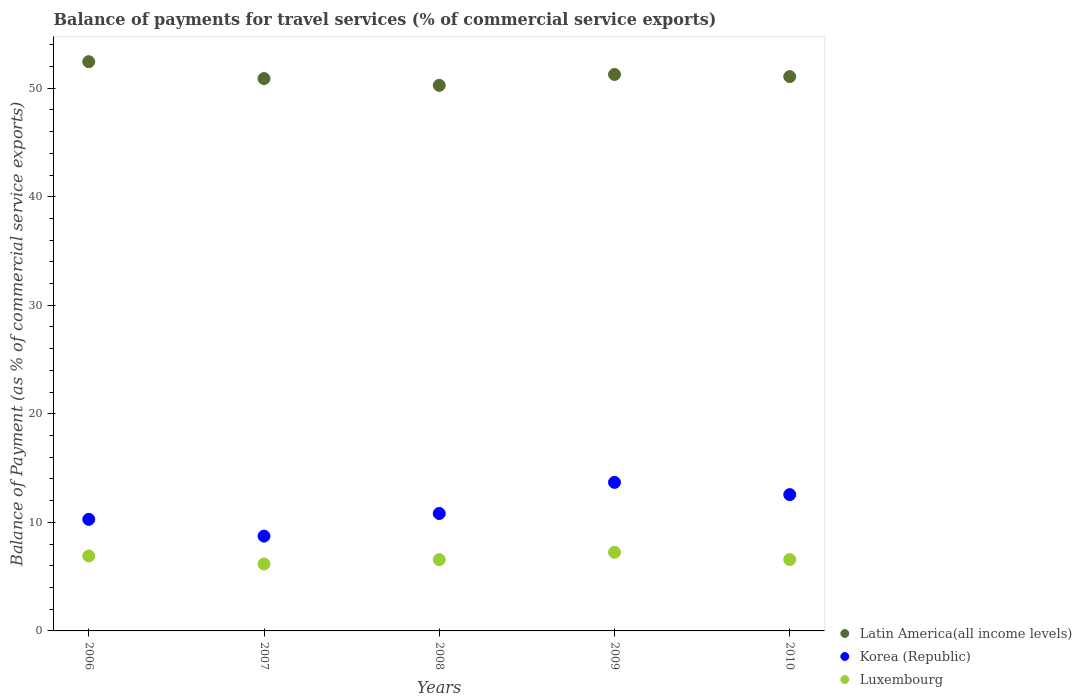Is the number of dotlines equal to the number of legend labels?
Your answer should be very brief. Yes. What is the balance of payments for travel services in Latin America(all income levels) in 2008?
Provide a short and direct response. 50.26. Across all years, what is the maximum balance of payments for travel services in Korea (Republic)?
Provide a succinct answer. 13.68. Across all years, what is the minimum balance of payments for travel services in Latin America(all income levels)?
Ensure brevity in your answer.  50.26. In which year was the balance of payments for travel services in Luxembourg maximum?
Your answer should be very brief. 2009. In which year was the balance of payments for travel services in Luxembourg minimum?
Ensure brevity in your answer.  2007. What is the total balance of payments for travel services in Luxembourg in the graph?
Give a very brief answer. 33.46. What is the difference between the balance of payments for travel services in Korea (Republic) in 2006 and that in 2010?
Give a very brief answer. -2.28. What is the difference between the balance of payments for travel services in Korea (Republic) in 2009 and the balance of payments for travel services in Luxembourg in 2008?
Offer a terse response. 7.12. What is the average balance of payments for travel services in Korea (Republic) per year?
Ensure brevity in your answer.  11.21. In the year 2008, what is the difference between the balance of payments for travel services in Luxembourg and balance of payments for travel services in Latin America(all income levels)?
Keep it short and to the point. -43.69. In how many years, is the balance of payments for travel services in Latin America(all income levels) greater than 46 %?
Offer a terse response. 5. What is the ratio of the balance of payments for travel services in Latin America(all income levels) in 2006 to that in 2010?
Provide a short and direct response. 1.03. Is the balance of payments for travel services in Luxembourg in 2008 less than that in 2010?
Your answer should be very brief. Yes. What is the difference between the highest and the second highest balance of payments for travel services in Latin America(all income levels)?
Provide a short and direct response. 1.18. What is the difference between the highest and the lowest balance of payments for travel services in Korea (Republic)?
Give a very brief answer. 4.95. In how many years, is the balance of payments for travel services in Korea (Republic) greater than the average balance of payments for travel services in Korea (Republic) taken over all years?
Your answer should be compact. 2. Is the sum of the balance of payments for travel services in Latin America(all income levels) in 2009 and 2010 greater than the maximum balance of payments for travel services in Korea (Republic) across all years?
Your response must be concise. Yes. Is the balance of payments for travel services in Luxembourg strictly greater than the balance of payments for travel services in Korea (Republic) over the years?
Keep it short and to the point. No. Is the balance of payments for travel services in Luxembourg strictly less than the balance of payments for travel services in Korea (Republic) over the years?
Your answer should be very brief. Yes. How many dotlines are there?
Provide a short and direct response. 3. How many years are there in the graph?
Your answer should be very brief. 5. What is the difference between two consecutive major ticks on the Y-axis?
Give a very brief answer. 10. Where does the legend appear in the graph?
Offer a very short reply. Bottom right. How are the legend labels stacked?
Offer a very short reply. Vertical. What is the title of the graph?
Your answer should be very brief. Balance of payments for travel services (% of commercial service exports). What is the label or title of the Y-axis?
Keep it short and to the point. Balance of Payment (as % of commercial service exports). What is the Balance of Payment (as % of commercial service exports) in Latin America(all income levels) in 2006?
Offer a very short reply. 52.44. What is the Balance of Payment (as % of commercial service exports) of Korea (Republic) in 2006?
Your answer should be compact. 10.28. What is the Balance of Payment (as % of commercial service exports) in Luxembourg in 2006?
Your answer should be very brief. 6.91. What is the Balance of Payment (as % of commercial service exports) of Latin America(all income levels) in 2007?
Give a very brief answer. 50.89. What is the Balance of Payment (as % of commercial service exports) of Korea (Republic) in 2007?
Keep it short and to the point. 8.73. What is the Balance of Payment (as % of commercial service exports) in Luxembourg in 2007?
Ensure brevity in your answer.  6.17. What is the Balance of Payment (as % of commercial service exports) of Latin America(all income levels) in 2008?
Provide a succinct answer. 50.26. What is the Balance of Payment (as % of commercial service exports) of Korea (Republic) in 2008?
Provide a short and direct response. 10.82. What is the Balance of Payment (as % of commercial service exports) of Luxembourg in 2008?
Provide a succinct answer. 6.57. What is the Balance of Payment (as % of commercial service exports) in Latin America(all income levels) in 2009?
Provide a short and direct response. 51.26. What is the Balance of Payment (as % of commercial service exports) in Korea (Republic) in 2009?
Give a very brief answer. 13.68. What is the Balance of Payment (as % of commercial service exports) in Luxembourg in 2009?
Offer a terse response. 7.24. What is the Balance of Payment (as % of commercial service exports) in Latin America(all income levels) in 2010?
Offer a terse response. 51.07. What is the Balance of Payment (as % of commercial service exports) in Korea (Republic) in 2010?
Your answer should be compact. 12.56. What is the Balance of Payment (as % of commercial service exports) in Luxembourg in 2010?
Your answer should be very brief. 6.58. Across all years, what is the maximum Balance of Payment (as % of commercial service exports) of Latin America(all income levels)?
Ensure brevity in your answer.  52.44. Across all years, what is the maximum Balance of Payment (as % of commercial service exports) in Korea (Republic)?
Make the answer very short. 13.68. Across all years, what is the maximum Balance of Payment (as % of commercial service exports) of Luxembourg?
Your response must be concise. 7.24. Across all years, what is the minimum Balance of Payment (as % of commercial service exports) in Latin America(all income levels)?
Provide a succinct answer. 50.26. Across all years, what is the minimum Balance of Payment (as % of commercial service exports) in Korea (Republic)?
Your answer should be compact. 8.73. Across all years, what is the minimum Balance of Payment (as % of commercial service exports) in Luxembourg?
Make the answer very short. 6.17. What is the total Balance of Payment (as % of commercial service exports) in Latin America(all income levels) in the graph?
Your answer should be compact. 255.92. What is the total Balance of Payment (as % of commercial service exports) of Korea (Republic) in the graph?
Your response must be concise. 56.07. What is the total Balance of Payment (as % of commercial service exports) of Luxembourg in the graph?
Make the answer very short. 33.46. What is the difference between the Balance of Payment (as % of commercial service exports) of Latin America(all income levels) in 2006 and that in 2007?
Give a very brief answer. 1.56. What is the difference between the Balance of Payment (as % of commercial service exports) in Korea (Republic) in 2006 and that in 2007?
Provide a succinct answer. 1.54. What is the difference between the Balance of Payment (as % of commercial service exports) of Luxembourg in 2006 and that in 2007?
Your response must be concise. 0.73. What is the difference between the Balance of Payment (as % of commercial service exports) of Latin America(all income levels) in 2006 and that in 2008?
Keep it short and to the point. 2.18. What is the difference between the Balance of Payment (as % of commercial service exports) in Korea (Republic) in 2006 and that in 2008?
Offer a very short reply. -0.54. What is the difference between the Balance of Payment (as % of commercial service exports) in Luxembourg in 2006 and that in 2008?
Provide a succinct answer. 0.34. What is the difference between the Balance of Payment (as % of commercial service exports) in Latin America(all income levels) in 2006 and that in 2009?
Offer a terse response. 1.18. What is the difference between the Balance of Payment (as % of commercial service exports) of Korea (Republic) in 2006 and that in 2009?
Offer a terse response. -3.41. What is the difference between the Balance of Payment (as % of commercial service exports) of Luxembourg in 2006 and that in 2009?
Your response must be concise. -0.34. What is the difference between the Balance of Payment (as % of commercial service exports) in Latin America(all income levels) in 2006 and that in 2010?
Provide a succinct answer. 1.37. What is the difference between the Balance of Payment (as % of commercial service exports) in Korea (Republic) in 2006 and that in 2010?
Provide a short and direct response. -2.28. What is the difference between the Balance of Payment (as % of commercial service exports) in Luxembourg in 2006 and that in 2010?
Your answer should be compact. 0.33. What is the difference between the Balance of Payment (as % of commercial service exports) of Latin America(all income levels) in 2007 and that in 2008?
Offer a terse response. 0.63. What is the difference between the Balance of Payment (as % of commercial service exports) in Korea (Republic) in 2007 and that in 2008?
Provide a short and direct response. -2.08. What is the difference between the Balance of Payment (as % of commercial service exports) of Luxembourg in 2007 and that in 2008?
Your answer should be very brief. -0.4. What is the difference between the Balance of Payment (as % of commercial service exports) in Latin America(all income levels) in 2007 and that in 2009?
Provide a short and direct response. -0.38. What is the difference between the Balance of Payment (as % of commercial service exports) of Korea (Republic) in 2007 and that in 2009?
Your response must be concise. -4.95. What is the difference between the Balance of Payment (as % of commercial service exports) in Luxembourg in 2007 and that in 2009?
Ensure brevity in your answer.  -1.07. What is the difference between the Balance of Payment (as % of commercial service exports) in Latin America(all income levels) in 2007 and that in 2010?
Give a very brief answer. -0.18. What is the difference between the Balance of Payment (as % of commercial service exports) in Korea (Republic) in 2007 and that in 2010?
Offer a terse response. -3.82. What is the difference between the Balance of Payment (as % of commercial service exports) in Luxembourg in 2007 and that in 2010?
Keep it short and to the point. -0.41. What is the difference between the Balance of Payment (as % of commercial service exports) of Latin America(all income levels) in 2008 and that in 2009?
Make the answer very short. -1. What is the difference between the Balance of Payment (as % of commercial service exports) of Korea (Republic) in 2008 and that in 2009?
Make the answer very short. -2.87. What is the difference between the Balance of Payment (as % of commercial service exports) of Luxembourg in 2008 and that in 2009?
Your answer should be compact. -0.68. What is the difference between the Balance of Payment (as % of commercial service exports) in Latin America(all income levels) in 2008 and that in 2010?
Keep it short and to the point. -0.81. What is the difference between the Balance of Payment (as % of commercial service exports) in Korea (Republic) in 2008 and that in 2010?
Your answer should be very brief. -1.74. What is the difference between the Balance of Payment (as % of commercial service exports) of Luxembourg in 2008 and that in 2010?
Offer a terse response. -0.01. What is the difference between the Balance of Payment (as % of commercial service exports) in Latin America(all income levels) in 2009 and that in 2010?
Your answer should be compact. 0.2. What is the difference between the Balance of Payment (as % of commercial service exports) of Korea (Republic) in 2009 and that in 2010?
Provide a short and direct response. 1.13. What is the difference between the Balance of Payment (as % of commercial service exports) of Luxembourg in 2009 and that in 2010?
Your response must be concise. 0.67. What is the difference between the Balance of Payment (as % of commercial service exports) in Latin America(all income levels) in 2006 and the Balance of Payment (as % of commercial service exports) in Korea (Republic) in 2007?
Keep it short and to the point. 43.71. What is the difference between the Balance of Payment (as % of commercial service exports) in Latin America(all income levels) in 2006 and the Balance of Payment (as % of commercial service exports) in Luxembourg in 2007?
Your response must be concise. 46.27. What is the difference between the Balance of Payment (as % of commercial service exports) of Korea (Republic) in 2006 and the Balance of Payment (as % of commercial service exports) of Luxembourg in 2007?
Make the answer very short. 4.11. What is the difference between the Balance of Payment (as % of commercial service exports) in Latin America(all income levels) in 2006 and the Balance of Payment (as % of commercial service exports) in Korea (Republic) in 2008?
Your response must be concise. 41.62. What is the difference between the Balance of Payment (as % of commercial service exports) of Latin America(all income levels) in 2006 and the Balance of Payment (as % of commercial service exports) of Luxembourg in 2008?
Your response must be concise. 45.88. What is the difference between the Balance of Payment (as % of commercial service exports) in Korea (Republic) in 2006 and the Balance of Payment (as % of commercial service exports) in Luxembourg in 2008?
Provide a short and direct response. 3.71. What is the difference between the Balance of Payment (as % of commercial service exports) in Latin America(all income levels) in 2006 and the Balance of Payment (as % of commercial service exports) in Korea (Republic) in 2009?
Keep it short and to the point. 38.76. What is the difference between the Balance of Payment (as % of commercial service exports) in Latin America(all income levels) in 2006 and the Balance of Payment (as % of commercial service exports) in Luxembourg in 2009?
Your answer should be very brief. 45.2. What is the difference between the Balance of Payment (as % of commercial service exports) of Korea (Republic) in 2006 and the Balance of Payment (as % of commercial service exports) of Luxembourg in 2009?
Your answer should be compact. 3.03. What is the difference between the Balance of Payment (as % of commercial service exports) in Latin America(all income levels) in 2006 and the Balance of Payment (as % of commercial service exports) in Korea (Republic) in 2010?
Give a very brief answer. 39.88. What is the difference between the Balance of Payment (as % of commercial service exports) in Latin America(all income levels) in 2006 and the Balance of Payment (as % of commercial service exports) in Luxembourg in 2010?
Your answer should be compact. 45.87. What is the difference between the Balance of Payment (as % of commercial service exports) in Korea (Republic) in 2006 and the Balance of Payment (as % of commercial service exports) in Luxembourg in 2010?
Make the answer very short. 3.7. What is the difference between the Balance of Payment (as % of commercial service exports) in Latin America(all income levels) in 2007 and the Balance of Payment (as % of commercial service exports) in Korea (Republic) in 2008?
Provide a short and direct response. 40.07. What is the difference between the Balance of Payment (as % of commercial service exports) in Latin America(all income levels) in 2007 and the Balance of Payment (as % of commercial service exports) in Luxembourg in 2008?
Offer a very short reply. 44.32. What is the difference between the Balance of Payment (as % of commercial service exports) of Korea (Republic) in 2007 and the Balance of Payment (as % of commercial service exports) of Luxembourg in 2008?
Keep it short and to the point. 2.17. What is the difference between the Balance of Payment (as % of commercial service exports) in Latin America(all income levels) in 2007 and the Balance of Payment (as % of commercial service exports) in Korea (Republic) in 2009?
Give a very brief answer. 37.2. What is the difference between the Balance of Payment (as % of commercial service exports) of Latin America(all income levels) in 2007 and the Balance of Payment (as % of commercial service exports) of Luxembourg in 2009?
Provide a succinct answer. 43.64. What is the difference between the Balance of Payment (as % of commercial service exports) in Korea (Republic) in 2007 and the Balance of Payment (as % of commercial service exports) in Luxembourg in 2009?
Offer a very short reply. 1.49. What is the difference between the Balance of Payment (as % of commercial service exports) in Latin America(all income levels) in 2007 and the Balance of Payment (as % of commercial service exports) in Korea (Republic) in 2010?
Ensure brevity in your answer.  38.33. What is the difference between the Balance of Payment (as % of commercial service exports) of Latin America(all income levels) in 2007 and the Balance of Payment (as % of commercial service exports) of Luxembourg in 2010?
Make the answer very short. 44.31. What is the difference between the Balance of Payment (as % of commercial service exports) of Korea (Republic) in 2007 and the Balance of Payment (as % of commercial service exports) of Luxembourg in 2010?
Your answer should be very brief. 2.16. What is the difference between the Balance of Payment (as % of commercial service exports) of Latin America(all income levels) in 2008 and the Balance of Payment (as % of commercial service exports) of Korea (Republic) in 2009?
Provide a short and direct response. 36.58. What is the difference between the Balance of Payment (as % of commercial service exports) of Latin America(all income levels) in 2008 and the Balance of Payment (as % of commercial service exports) of Luxembourg in 2009?
Offer a very short reply. 43.02. What is the difference between the Balance of Payment (as % of commercial service exports) in Korea (Republic) in 2008 and the Balance of Payment (as % of commercial service exports) in Luxembourg in 2009?
Provide a succinct answer. 3.57. What is the difference between the Balance of Payment (as % of commercial service exports) in Latin America(all income levels) in 2008 and the Balance of Payment (as % of commercial service exports) in Korea (Republic) in 2010?
Give a very brief answer. 37.7. What is the difference between the Balance of Payment (as % of commercial service exports) of Latin America(all income levels) in 2008 and the Balance of Payment (as % of commercial service exports) of Luxembourg in 2010?
Offer a very short reply. 43.69. What is the difference between the Balance of Payment (as % of commercial service exports) in Korea (Republic) in 2008 and the Balance of Payment (as % of commercial service exports) in Luxembourg in 2010?
Ensure brevity in your answer.  4.24. What is the difference between the Balance of Payment (as % of commercial service exports) of Latin America(all income levels) in 2009 and the Balance of Payment (as % of commercial service exports) of Korea (Republic) in 2010?
Your response must be concise. 38.71. What is the difference between the Balance of Payment (as % of commercial service exports) of Latin America(all income levels) in 2009 and the Balance of Payment (as % of commercial service exports) of Luxembourg in 2010?
Give a very brief answer. 44.69. What is the difference between the Balance of Payment (as % of commercial service exports) of Korea (Republic) in 2009 and the Balance of Payment (as % of commercial service exports) of Luxembourg in 2010?
Keep it short and to the point. 7.11. What is the average Balance of Payment (as % of commercial service exports) in Latin America(all income levels) per year?
Offer a very short reply. 51.18. What is the average Balance of Payment (as % of commercial service exports) in Korea (Republic) per year?
Your answer should be compact. 11.21. What is the average Balance of Payment (as % of commercial service exports) of Luxembourg per year?
Ensure brevity in your answer.  6.69. In the year 2006, what is the difference between the Balance of Payment (as % of commercial service exports) in Latin America(all income levels) and Balance of Payment (as % of commercial service exports) in Korea (Republic)?
Provide a succinct answer. 42.16. In the year 2006, what is the difference between the Balance of Payment (as % of commercial service exports) in Latin America(all income levels) and Balance of Payment (as % of commercial service exports) in Luxembourg?
Make the answer very short. 45.54. In the year 2006, what is the difference between the Balance of Payment (as % of commercial service exports) of Korea (Republic) and Balance of Payment (as % of commercial service exports) of Luxembourg?
Make the answer very short. 3.37. In the year 2007, what is the difference between the Balance of Payment (as % of commercial service exports) of Latin America(all income levels) and Balance of Payment (as % of commercial service exports) of Korea (Republic)?
Offer a terse response. 42.15. In the year 2007, what is the difference between the Balance of Payment (as % of commercial service exports) in Latin America(all income levels) and Balance of Payment (as % of commercial service exports) in Luxembourg?
Offer a very short reply. 44.72. In the year 2007, what is the difference between the Balance of Payment (as % of commercial service exports) of Korea (Republic) and Balance of Payment (as % of commercial service exports) of Luxembourg?
Your answer should be very brief. 2.56. In the year 2008, what is the difference between the Balance of Payment (as % of commercial service exports) of Latin America(all income levels) and Balance of Payment (as % of commercial service exports) of Korea (Republic)?
Give a very brief answer. 39.44. In the year 2008, what is the difference between the Balance of Payment (as % of commercial service exports) of Latin America(all income levels) and Balance of Payment (as % of commercial service exports) of Luxembourg?
Your answer should be compact. 43.69. In the year 2008, what is the difference between the Balance of Payment (as % of commercial service exports) of Korea (Republic) and Balance of Payment (as % of commercial service exports) of Luxembourg?
Make the answer very short. 4.25. In the year 2009, what is the difference between the Balance of Payment (as % of commercial service exports) in Latin America(all income levels) and Balance of Payment (as % of commercial service exports) in Korea (Republic)?
Offer a very short reply. 37.58. In the year 2009, what is the difference between the Balance of Payment (as % of commercial service exports) in Latin America(all income levels) and Balance of Payment (as % of commercial service exports) in Luxembourg?
Provide a succinct answer. 44.02. In the year 2009, what is the difference between the Balance of Payment (as % of commercial service exports) in Korea (Republic) and Balance of Payment (as % of commercial service exports) in Luxembourg?
Your response must be concise. 6.44. In the year 2010, what is the difference between the Balance of Payment (as % of commercial service exports) of Latin America(all income levels) and Balance of Payment (as % of commercial service exports) of Korea (Republic)?
Provide a short and direct response. 38.51. In the year 2010, what is the difference between the Balance of Payment (as % of commercial service exports) in Latin America(all income levels) and Balance of Payment (as % of commercial service exports) in Luxembourg?
Provide a short and direct response. 44.49. In the year 2010, what is the difference between the Balance of Payment (as % of commercial service exports) in Korea (Republic) and Balance of Payment (as % of commercial service exports) in Luxembourg?
Offer a very short reply. 5.98. What is the ratio of the Balance of Payment (as % of commercial service exports) of Latin America(all income levels) in 2006 to that in 2007?
Give a very brief answer. 1.03. What is the ratio of the Balance of Payment (as % of commercial service exports) in Korea (Republic) in 2006 to that in 2007?
Make the answer very short. 1.18. What is the ratio of the Balance of Payment (as % of commercial service exports) in Luxembourg in 2006 to that in 2007?
Give a very brief answer. 1.12. What is the ratio of the Balance of Payment (as % of commercial service exports) of Latin America(all income levels) in 2006 to that in 2008?
Offer a terse response. 1.04. What is the ratio of the Balance of Payment (as % of commercial service exports) of Korea (Republic) in 2006 to that in 2008?
Your answer should be compact. 0.95. What is the ratio of the Balance of Payment (as % of commercial service exports) of Luxembourg in 2006 to that in 2008?
Your answer should be compact. 1.05. What is the ratio of the Balance of Payment (as % of commercial service exports) of Latin America(all income levels) in 2006 to that in 2009?
Offer a terse response. 1.02. What is the ratio of the Balance of Payment (as % of commercial service exports) in Korea (Republic) in 2006 to that in 2009?
Your answer should be very brief. 0.75. What is the ratio of the Balance of Payment (as % of commercial service exports) of Luxembourg in 2006 to that in 2009?
Your answer should be very brief. 0.95. What is the ratio of the Balance of Payment (as % of commercial service exports) in Latin America(all income levels) in 2006 to that in 2010?
Make the answer very short. 1.03. What is the ratio of the Balance of Payment (as % of commercial service exports) of Korea (Republic) in 2006 to that in 2010?
Give a very brief answer. 0.82. What is the ratio of the Balance of Payment (as % of commercial service exports) in Luxembourg in 2006 to that in 2010?
Provide a short and direct response. 1.05. What is the ratio of the Balance of Payment (as % of commercial service exports) in Latin America(all income levels) in 2007 to that in 2008?
Your answer should be compact. 1.01. What is the ratio of the Balance of Payment (as % of commercial service exports) of Korea (Republic) in 2007 to that in 2008?
Provide a short and direct response. 0.81. What is the ratio of the Balance of Payment (as % of commercial service exports) of Luxembourg in 2007 to that in 2008?
Keep it short and to the point. 0.94. What is the ratio of the Balance of Payment (as % of commercial service exports) in Latin America(all income levels) in 2007 to that in 2009?
Offer a very short reply. 0.99. What is the ratio of the Balance of Payment (as % of commercial service exports) of Korea (Republic) in 2007 to that in 2009?
Your answer should be compact. 0.64. What is the ratio of the Balance of Payment (as % of commercial service exports) in Luxembourg in 2007 to that in 2009?
Your response must be concise. 0.85. What is the ratio of the Balance of Payment (as % of commercial service exports) in Latin America(all income levels) in 2007 to that in 2010?
Keep it short and to the point. 1. What is the ratio of the Balance of Payment (as % of commercial service exports) of Korea (Republic) in 2007 to that in 2010?
Your answer should be very brief. 0.7. What is the ratio of the Balance of Payment (as % of commercial service exports) in Luxembourg in 2007 to that in 2010?
Your answer should be compact. 0.94. What is the ratio of the Balance of Payment (as % of commercial service exports) in Latin America(all income levels) in 2008 to that in 2009?
Ensure brevity in your answer.  0.98. What is the ratio of the Balance of Payment (as % of commercial service exports) in Korea (Republic) in 2008 to that in 2009?
Provide a succinct answer. 0.79. What is the ratio of the Balance of Payment (as % of commercial service exports) in Luxembourg in 2008 to that in 2009?
Keep it short and to the point. 0.91. What is the ratio of the Balance of Payment (as % of commercial service exports) in Latin America(all income levels) in 2008 to that in 2010?
Make the answer very short. 0.98. What is the ratio of the Balance of Payment (as % of commercial service exports) in Korea (Republic) in 2008 to that in 2010?
Ensure brevity in your answer.  0.86. What is the ratio of the Balance of Payment (as % of commercial service exports) of Korea (Republic) in 2009 to that in 2010?
Offer a very short reply. 1.09. What is the ratio of the Balance of Payment (as % of commercial service exports) of Luxembourg in 2009 to that in 2010?
Offer a very short reply. 1.1. What is the difference between the highest and the second highest Balance of Payment (as % of commercial service exports) in Latin America(all income levels)?
Offer a terse response. 1.18. What is the difference between the highest and the second highest Balance of Payment (as % of commercial service exports) in Korea (Republic)?
Offer a terse response. 1.13. What is the difference between the highest and the second highest Balance of Payment (as % of commercial service exports) in Luxembourg?
Provide a succinct answer. 0.34. What is the difference between the highest and the lowest Balance of Payment (as % of commercial service exports) of Latin America(all income levels)?
Ensure brevity in your answer.  2.18. What is the difference between the highest and the lowest Balance of Payment (as % of commercial service exports) in Korea (Republic)?
Ensure brevity in your answer.  4.95. What is the difference between the highest and the lowest Balance of Payment (as % of commercial service exports) in Luxembourg?
Give a very brief answer. 1.07. 